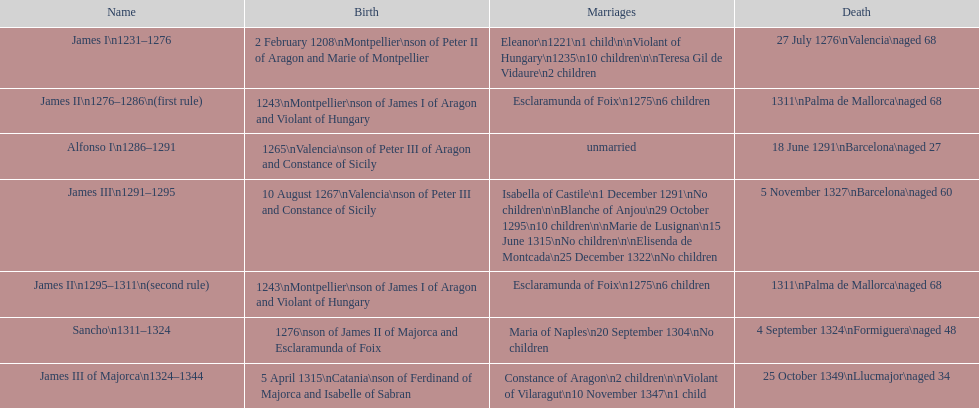Did james iii or sancho arrive in the world in the year 1276? Sancho. 